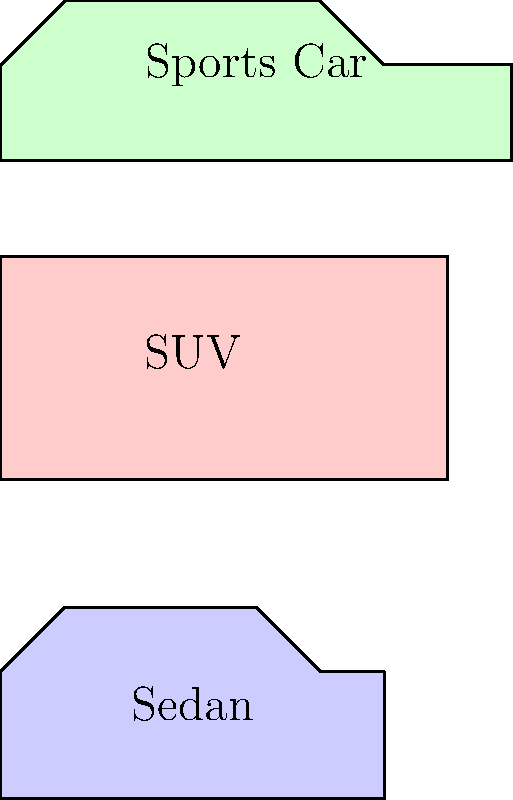As a photographer documenting unique car cultures, you encounter various car types with distinct silhouettes. Based on the simplified outlines shown, which two car types have the most similar length-to-height ratio? To determine which two car types have the most similar length-to-height ratio, we need to calculate and compare the ratios for each car type:

1. Sedan:
   Length: 60 units
   Height: 30 units
   Ratio = 60/30 = 2

2. SUV:
   Length: 70 units
   Height: 35 units
   Ratio = 70/35 = 2

3. Sports Car:
   Length: 80 units
   Height: 25 units
   Ratio = 80/25 = 3.2

Comparing the ratios:
- Sedan: 2
- SUV: 2
- Sports Car: 3.2

We can see that the Sedan and SUV have identical length-to-height ratios of 2, while the Sports Car has a significantly different ratio of 3.2.

Therefore, the Sedan and SUV have the most similar length-to-height ratio.
Answer: Sedan and SUV 